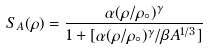Convert formula to latex. <formula><loc_0><loc_0><loc_500><loc_500>S _ { A } ( \rho ) = \frac { \alpha ( \rho / \rho _ { \circ } ) ^ { \gamma } } { 1 + [ \alpha ( \rho / \rho _ { \circ } ) ^ { \gamma } / \beta A ^ { 1 / 3 } ] }</formula> 